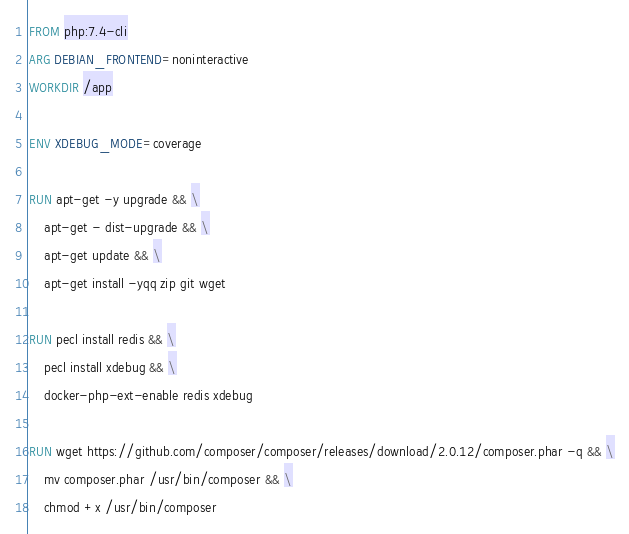Convert code to text. <code><loc_0><loc_0><loc_500><loc_500><_Dockerfile_>FROM php:7.4-cli
ARG DEBIAN_FRONTEND=noninteractive
WORKDIR /app

ENV XDEBUG_MODE=coverage

RUN apt-get -y upgrade && \
    apt-get - dist-upgrade && \
    apt-get update && \
    apt-get install -yqq zip git wget

RUN pecl install redis && \
    pecl install xdebug && \
    docker-php-ext-enable redis xdebug

RUN wget https://github.com/composer/composer/releases/download/2.0.12/composer.phar -q && \
    mv composer.phar /usr/bin/composer && \
    chmod +x /usr/bin/composer
</code> 